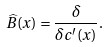Convert formula to latex. <formula><loc_0><loc_0><loc_500><loc_500>\widehat { B } ( x ) = \frac { \delta } { \delta c ^ { \prime } ( x ) } .</formula> 